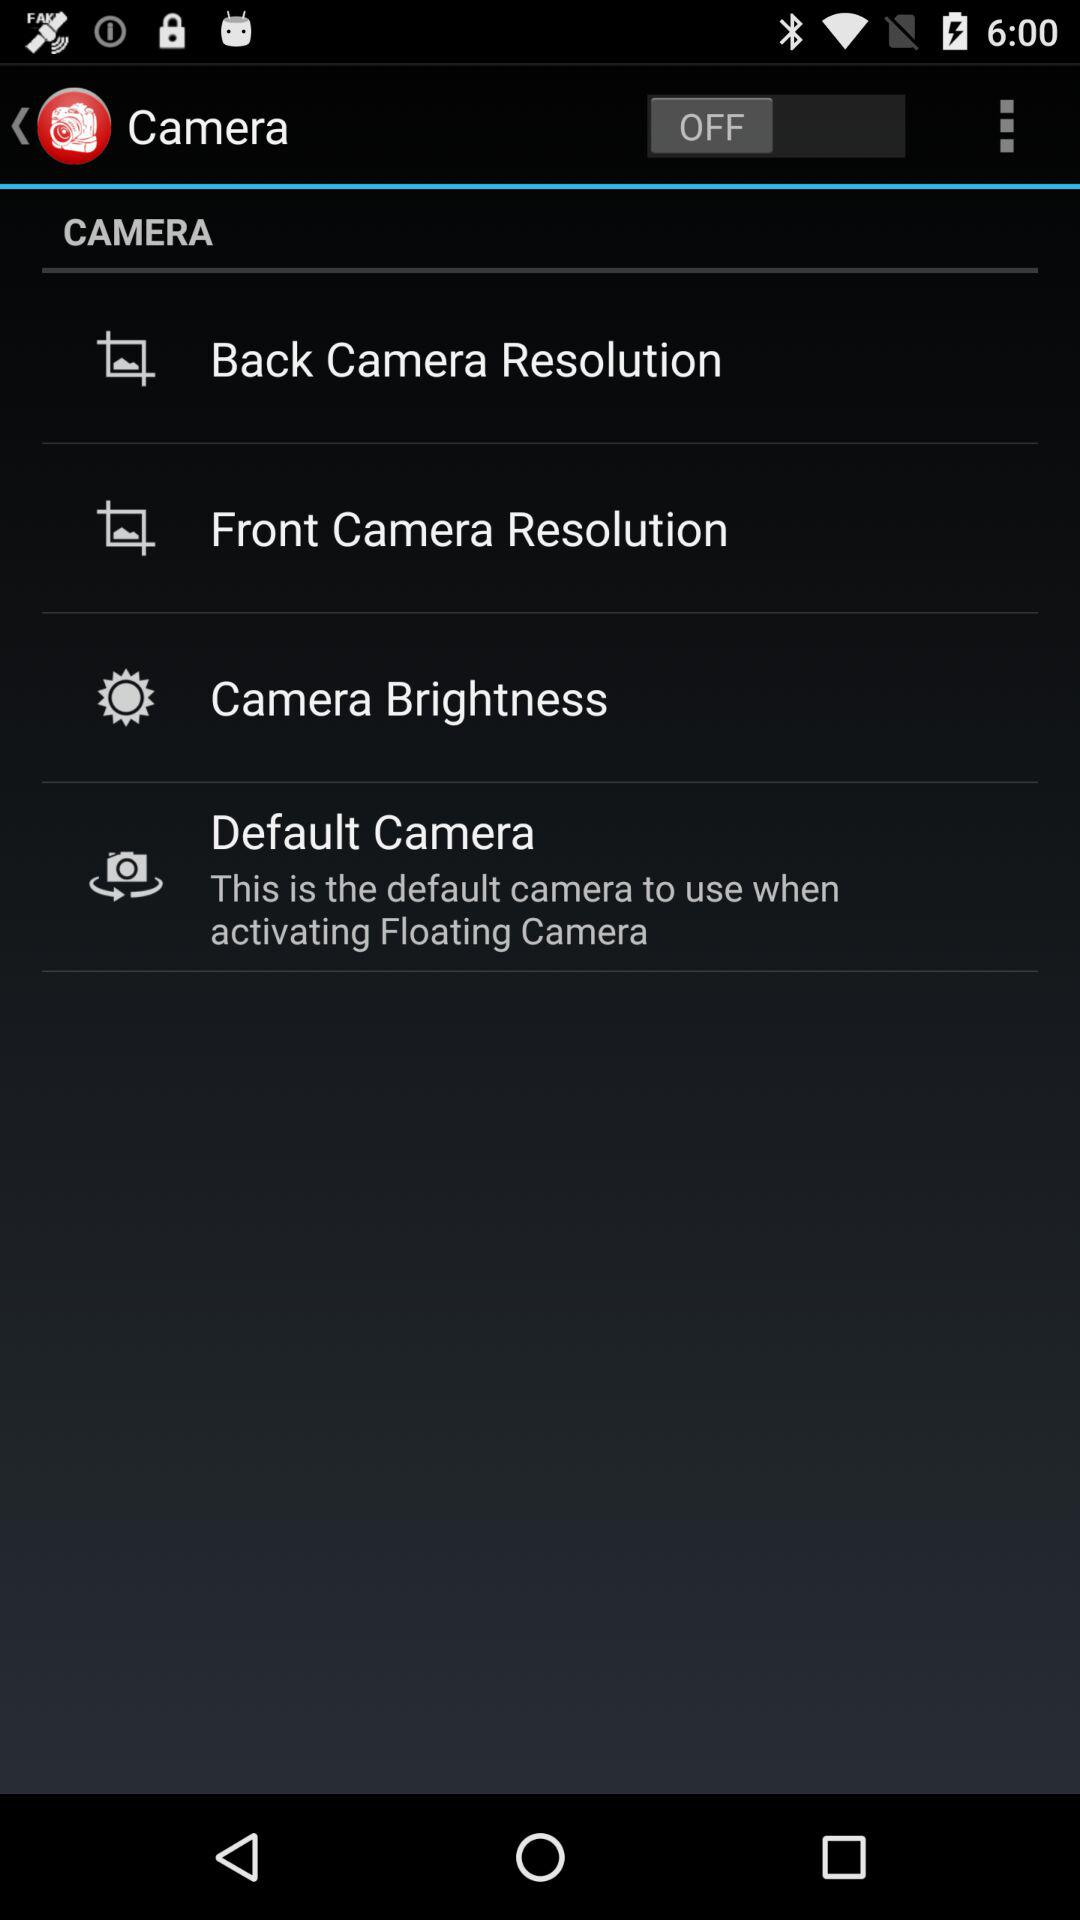What is the default camera? The default camera is "This is the default camera to use when activating Floating Camera". 